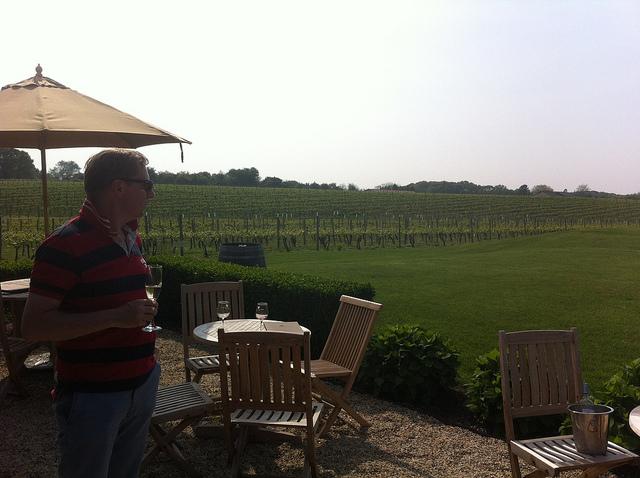What is the color of the grass?
Concise answer only. Green. Is the man wearing a hat?
Keep it brief. No. What kind of glasses are on the table?
Be succinct. Wine. How many chairs are visible?
Write a very short answer. 5. 